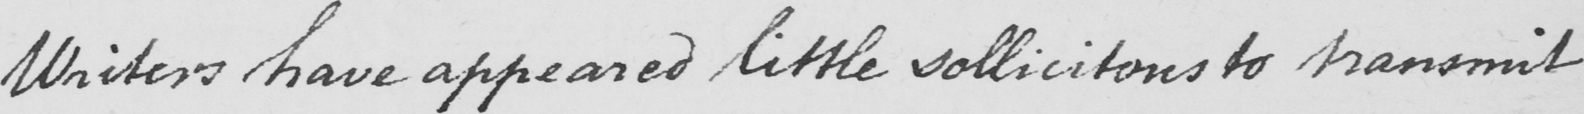Can you read and transcribe this handwriting? Writers have appeared little sollicitous to transmit 